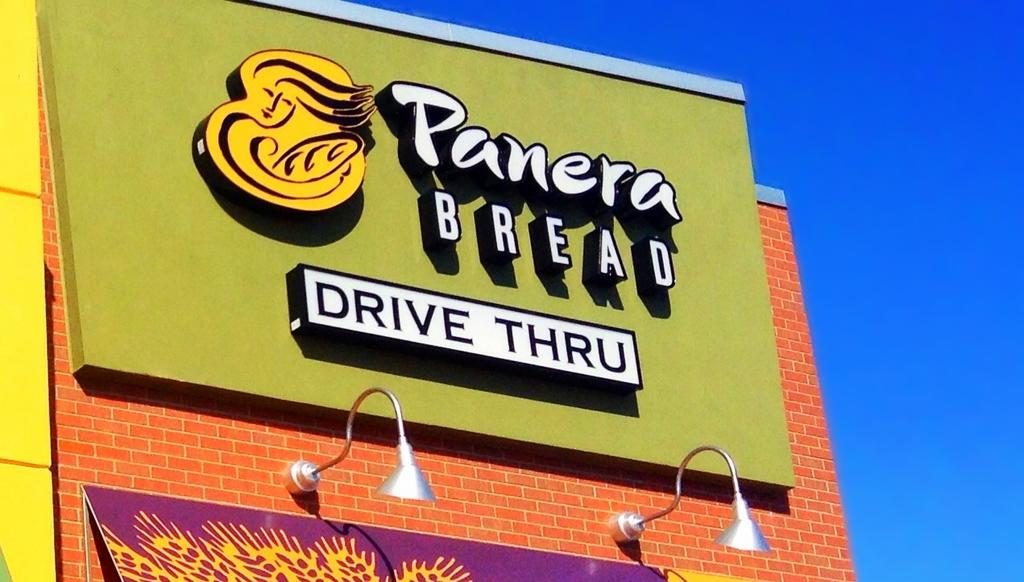<image>
Render a clear and concise summary of the photo. A colorful drive-thru sign with the words Panera BREAD. 